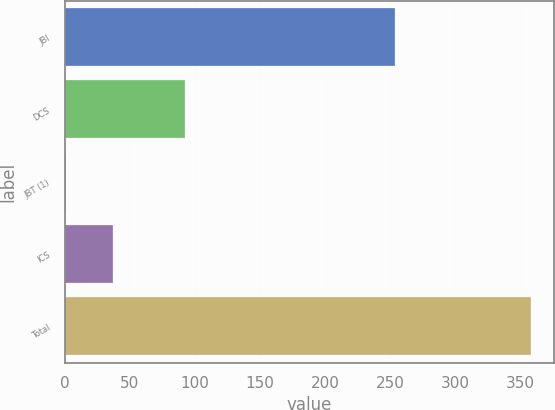<chart> <loc_0><loc_0><loc_500><loc_500><bar_chart><fcel>JBI<fcel>DCS<fcel>JBT (1)<fcel>ICS<fcel>Total<nl><fcel>254<fcel>92<fcel>1<fcel>36.7<fcel>358<nl></chart> 